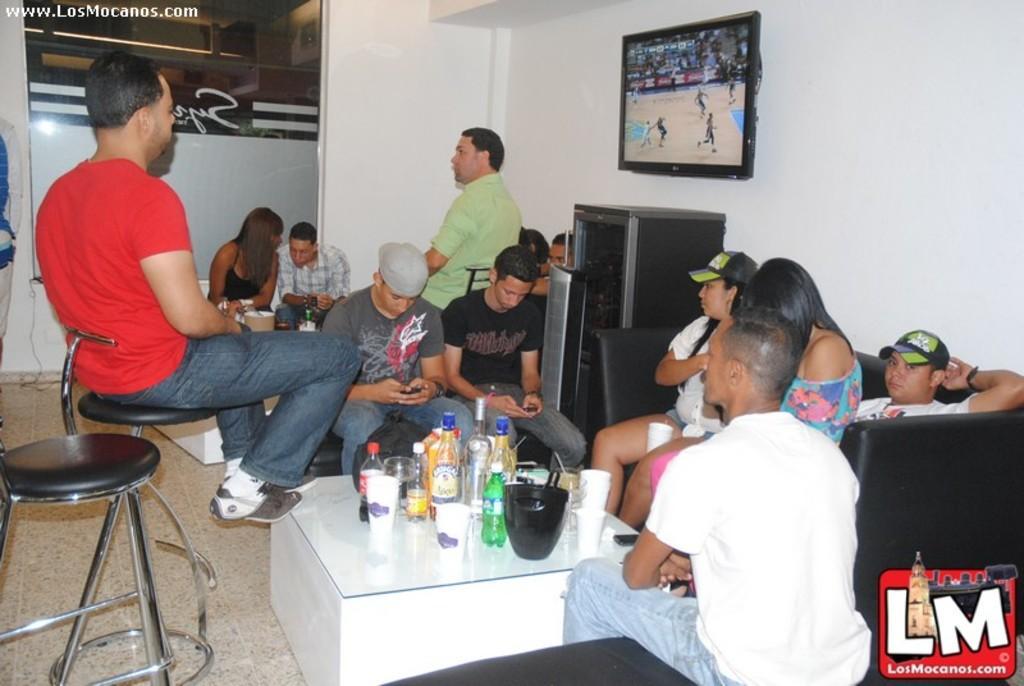Please provide a concise description of this image. In this image there is a person and chair in the left corner. There are people, chairs, table with bottles and other objects on it in the foreground. There is sofa, people, a screen on the wall and some text in the right corner. There is wall, people chair in the background. And there is a floor at the bottom. 